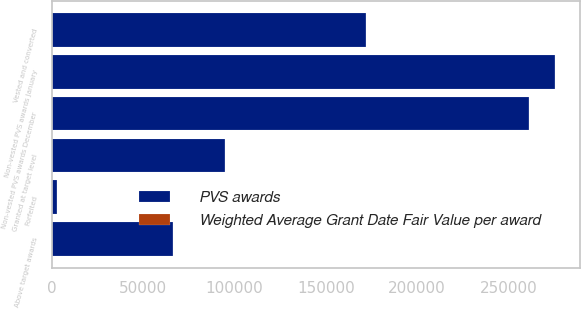Convert chart to OTSL. <chart><loc_0><loc_0><loc_500><loc_500><stacked_bar_chart><ecel><fcel>Non-vested PVS awards January<fcel>Granted at target level<fcel>Above target awards<fcel>Vested and converted<fcel>Forfeited<fcel>Non-vested PVS awards December<nl><fcel>PVS awards<fcel>275145<fcel>94571<fcel>66391<fcel>171891<fcel>3085<fcel>261131<nl><fcel>Weighted Average Grant Date Fair Value per award<fcel>25.35<fcel>44.96<fcel>19.41<fcel>19.41<fcel>28.79<fcel>34.81<nl></chart> 